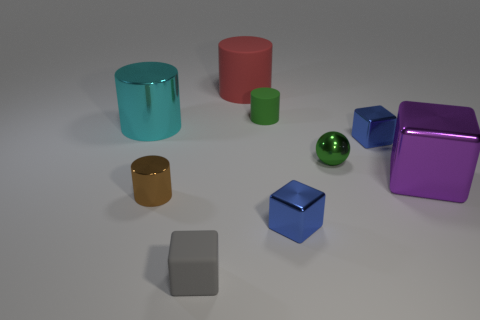Subtract all blue cubes. How many were subtracted if there are1blue cubes left? 1 Subtract all purple cylinders. How many blue cubes are left? 2 Subtract all tiny metallic cylinders. How many cylinders are left? 3 Subtract 1 cylinders. How many cylinders are left? 3 Subtract all red cylinders. How many cylinders are left? 3 Subtract all yellow cylinders. Subtract all brown balls. How many cylinders are left? 4 Subtract all cylinders. How many objects are left? 5 Subtract all tiny cubes. Subtract all big purple metallic blocks. How many objects are left? 5 Add 1 green shiny spheres. How many green shiny spheres are left? 2 Add 5 brown cylinders. How many brown cylinders exist? 6 